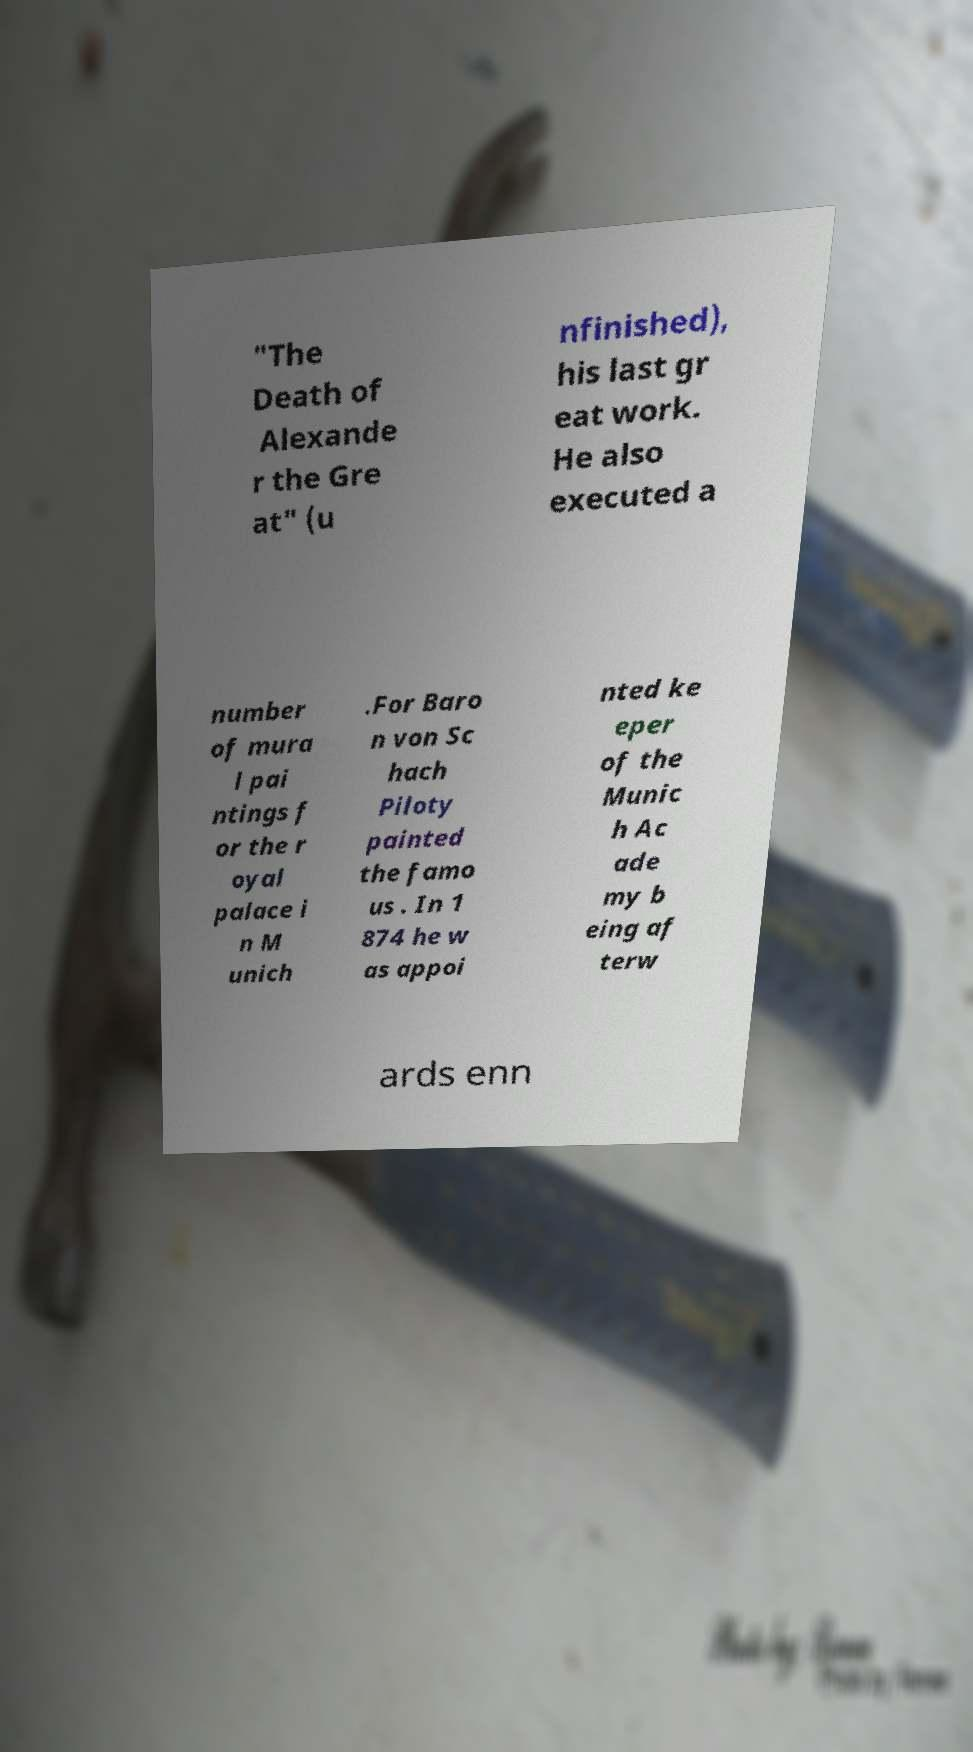Could you assist in decoding the text presented in this image and type it out clearly? "The Death of Alexande r the Gre at" (u nfinished), his last gr eat work. He also executed a number of mura l pai ntings f or the r oyal palace i n M unich .For Baro n von Sc hach Piloty painted the famo us . In 1 874 he w as appoi nted ke eper of the Munic h Ac ade my b eing af terw ards enn 